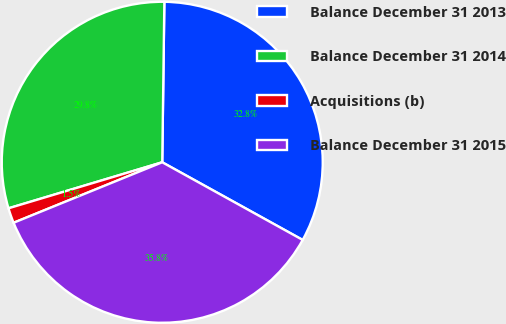<chart> <loc_0><loc_0><loc_500><loc_500><pie_chart><fcel>Balance December 31 2013<fcel>Balance December 31 2014<fcel>Acquisitions (b)<fcel>Balance December 31 2015<nl><fcel>32.83%<fcel>29.84%<fcel>1.52%<fcel>35.81%<nl></chart> 